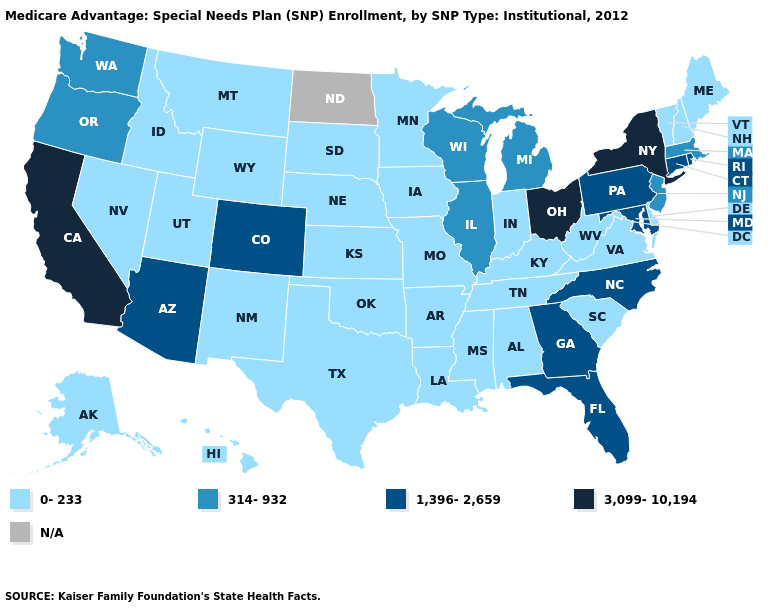How many symbols are there in the legend?
Answer briefly. 5. Name the states that have a value in the range 314-932?
Short answer required. Illinois, Massachusetts, Michigan, New Jersey, Oregon, Washington, Wisconsin. What is the value of Wisconsin?
Give a very brief answer. 314-932. What is the lowest value in states that border Nebraska?
Short answer required. 0-233. Which states have the highest value in the USA?
Be succinct. California, New York, Ohio. Does the first symbol in the legend represent the smallest category?
Give a very brief answer. Yes. What is the value of Ohio?
Write a very short answer. 3,099-10,194. Which states hav the highest value in the MidWest?
Short answer required. Ohio. Which states have the lowest value in the USA?
Be succinct. Alaska, Alabama, Arkansas, Delaware, Hawaii, Iowa, Idaho, Indiana, Kansas, Kentucky, Louisiana, Maine, Minnesota, Missouri, Mississippi, Montana, Nebraska, New Hampshire, New Mexico, Nevada, Oklahoma, South Carolina, South Dakota, Tennessee, Texas, Utah, Virginia, Vermont, West Virginia, Wyoming. Among the states that border Maine , which have the highest value?
Write a very short answer. New Hampshire. What is the highest value in the USA?
Give a very brief answer. 3,099-10,194. What is the highest value in the USA?
Quick response, please. 3,099-10,194. Does New York have the highest value in the Northeast?
Short answer required. Yes. Among the states that border Indiana , does Illinois have the highest value?
Quick response, please. No. 